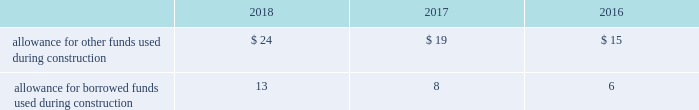Investment tax credits have been deferred by the regulated utility subsidiaries and are being amortized to income over the average estimated service lives of the related assets .
The company recognizes accrued interest and penalties related to tax positions as a component of income tax expense and accounts for sales tax collected from customers and remitted to taxing authorities on a net basis .
See note 14 2014income taxes for additional information .
Allowance for funds used during construction afudc is a non-cash credit to income with a corresponding charge to utility plant that represents the cost of borrowed funds or a return on equity funds devoted to plant under construction .
The regulated utility subsidiaries record afudc to the extent permitted by the pucs .
The portion of afudc attributable to borrowed funds is shown as a reduction of interest , net on the consolidated statements of operations .
Any portion of afudc attributable to equity funds would be included in other , net on the consolidated statements of operations .
Afudc is provided in the table for the years ended december 31: .
Environmental costs the company 2019s water and wastewater operations and the operations of its market-based businesses are subject to u.s .
Federal , state , local and foreign requirements relating to environmental protection , and as such , the company periodically becomes subject to environmental claims in the normal course of business .
Environmental expenditures that relate to current operations or provide a future benefit are expensed or capitalized as appropriate .
Remediation costs that relate to an existing condition caused by past operations are accrued , on an undiscounted basis , when it is probable that these costs will be incurred and can be reasonably estimated .
A conservation agreement entered into by a subsidiary of the company with the national oceanic and atmospheric administration in 2010 and amended in 2017 required the subsidiary to , among other provisions , implement certain measures to protect the steelhead trout and its habitat in the carmel river watershed in the state of california .
The subsidiary agreed to pay $ 1 million annually commencing in 2010 with the final payment being made in 2021 .
Remediation costs accrued amounted to $ 4 million and $ 6 million as of december 31 , 2018 and 2017 , respectively .
Derivative financial instruments the company uses derivative financial instruments for purposes of hedging exposures to fluctuations in interest rates .
These derivative contracts are entered into for periods consistent with the related underlying exposures and do not constitute positions independent of those exposures .
The company does not enter into derivative contracts for speculative purposes and does not use leveraged instruments .
All derivatives are recognized on the balance sheet at fair value .
On the date the derivative contract is entered into , the company may designate the derivative as a hedge of the fair value of a recognized asset or liability ( fair-value hedge ) or a hedge of a forecasted transaction or of the variability of cash flows to be received or paid related to a recognized asset or liability ( cash-flow hedge ) .
Changes in the fair value of a fair-value hedge , along with the gain or loss on the underlying hedged item , are recorded in current-period earnings .
The gains and losses on the effective portion of cash-flow hedges are recorded in other comprehensive income , until earnings are affected by the variability of cash flows .
Any ineffective portion of designated cash-flow hedges is recognized in current-period earnings. .
By how much did allowance for other funds used during construction increase from 2016 to 2018? 
Computations: ((24 - 15) / 15)
Answer: 0.6. 